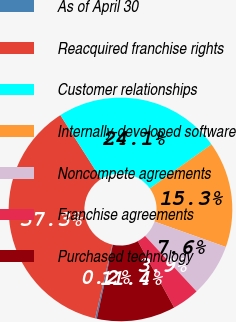Convert chart to OTSL. <chart><loc_0><loc_0><loc_500><loc_500><pie_chart><fcel>As of April 30<fcel>Reacquired franchise rights<fcel>Customer relationships<fcel>Internally-developed software<fcel>Noncompete agreements<fcel>Franchise agreements<fcel>Purchased technology<nl><fcel>0.24%<fcel>37.33%<fcel>24.15%<fcel>15.33%<fcel>7.65%<fcel>3.94%<fcel>11.36%<nl></chart> 